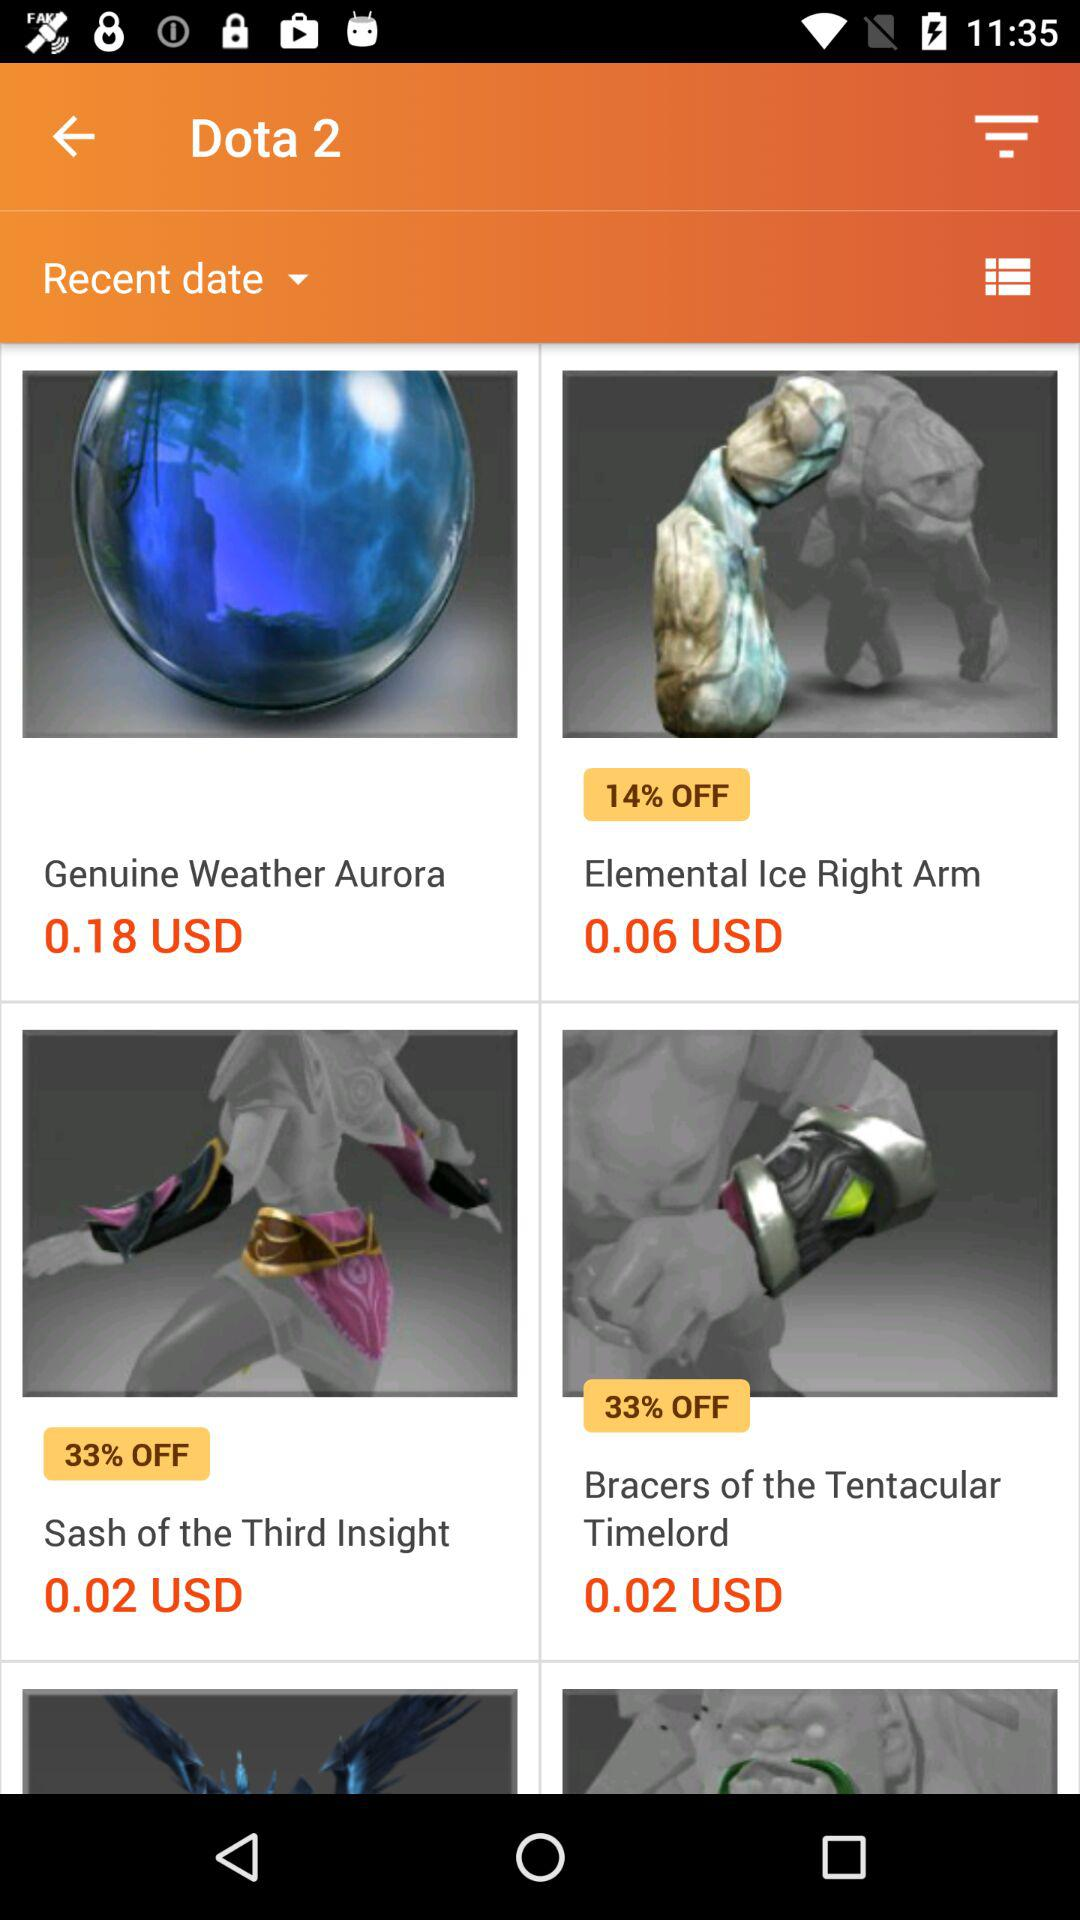What is the price of "Ice Right Arm"? The price of "Ice Right Arm" is 0.06 USD. 